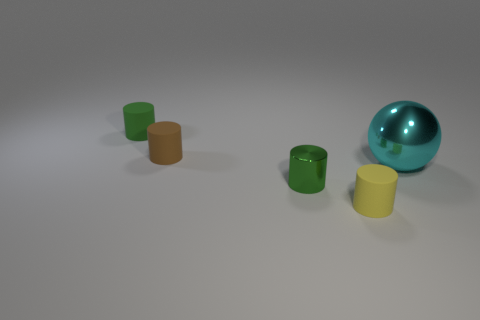Add 3 cyan metal spheres. How many objects exist? 8 Subtract all cylinders. How many objects are left? 1 Subtract 0 gray cylinders. How many objects are left? 5 Subtract all metal cylinders. Subtract all large cyan metal spheres. How many objects are left? 3 Add 3 small objects. How many small objects are left? 7 Add 2 big yellow metal things. How many big yellow metal things exist? 2 